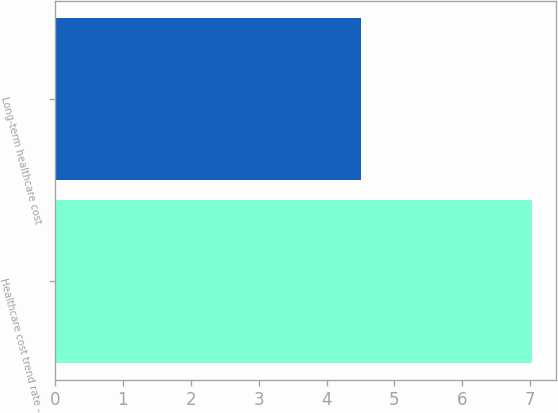Convert chart. <chart><loc_0><loc_0><loc_500><loc_500><bar_chart><fcel>Healthcare cost trend rate -<fcel>Long-term healthcare cost<nl><fcel>7.03<fcel>4.5<nl></chart> 